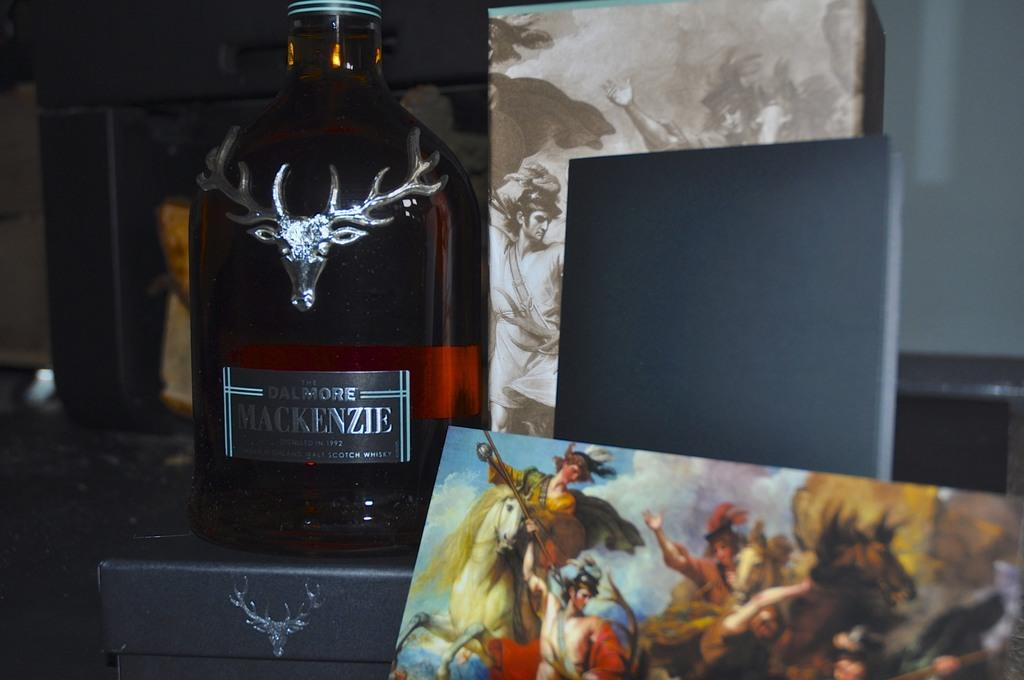<image>
Share a concise interpretation of the image provided. The Dalmore Mackenzie scotch sitting next to a small card of a battle. 